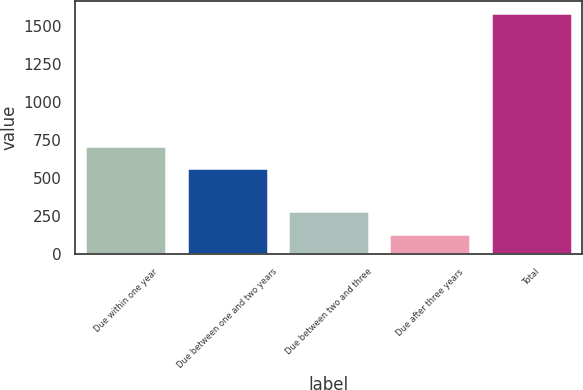Convert chart to OTSL. <chart><loc_0><loc_0><loc_500><loc_500><bar_chart><fcel>Due within one year<fcel>Due between one and two years<fcel>Due between two and three<fcel>Due after three years<fcel>Total<nl><fcel>710.05<fcel>564.2<fcel>282.2<fcel>127.7<fcel>1586.2<nl></chart> 